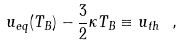<formula> <loc_0><loc_0><loc_500><loc_500>u _ { e q } ( T _ { B } ) - \frac { 3 } { 2 } \kappa T _ { B } \equiv u _ { t h } \ ,</formula> 